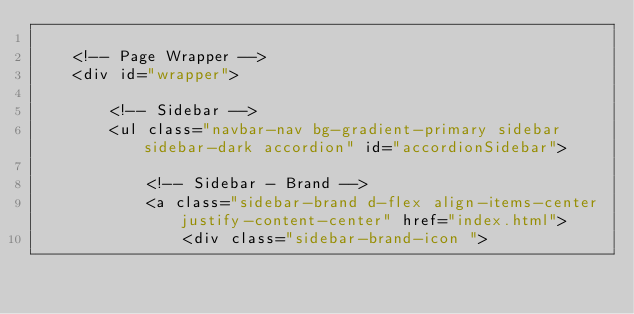Convert code to text. <code><loc_0><loc_0><loc_500><loc_500><_PHP_>
    <!-- Page Wrapper -->
    <div id="wrapper">

        <!-- Sidebar -->
        <ul class="navbar-nav bg-gradient-primary sidebar sidebar-dark accordion" id="accordionSidebar">

            <!-- Sidebar - Brand -->
            <a class="sidebar-brand d-flex align-items-center justify-content-center" href="index.html">
                <div class="sidebar-brand-icon "></code> 